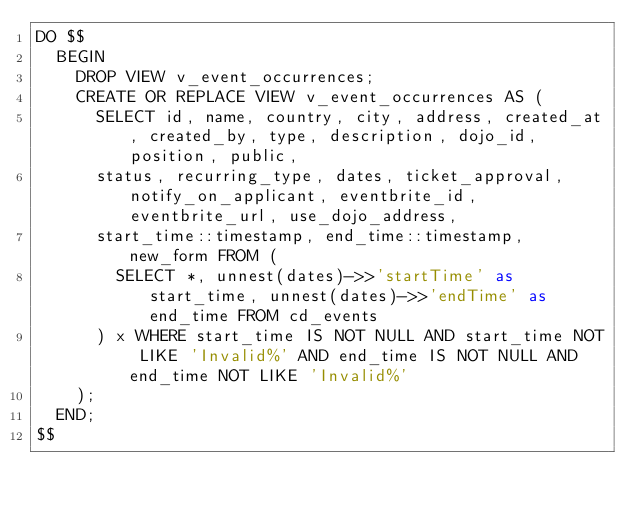Convert code to text. <code><loc_0><loc_0><loc_500><loc_500><_SQL_>DO $$
  BEGIN
    DROP VIEW v_event_occurrences;
    CREATE OR REPLACE VIEW v_event_occurrences AS (
      SELECT id, name, country, city, address, created_at, created_by, type, description, dojo_id, position, public,
      status, recurring_type, dates, ticket_approval, notify_on_applicant, eventbrite_id, eventbrite_url, use_dojo_address,
      start_time::timestamp, end_time::timestamp, new_form FROM (
        SELECT *, unnest(dates)->>'startTime' as start_time, unnest(dates)->>'endTime' as end_time FROM cd_events
      ) x WHERE start_time IS NOT NULL AND start_time NOT LIKE 'Invalid%' AND end_time IS NOT NULL AND end_time NOT LIKE 'Invalid%'
    );
  END;
$$
</code> 